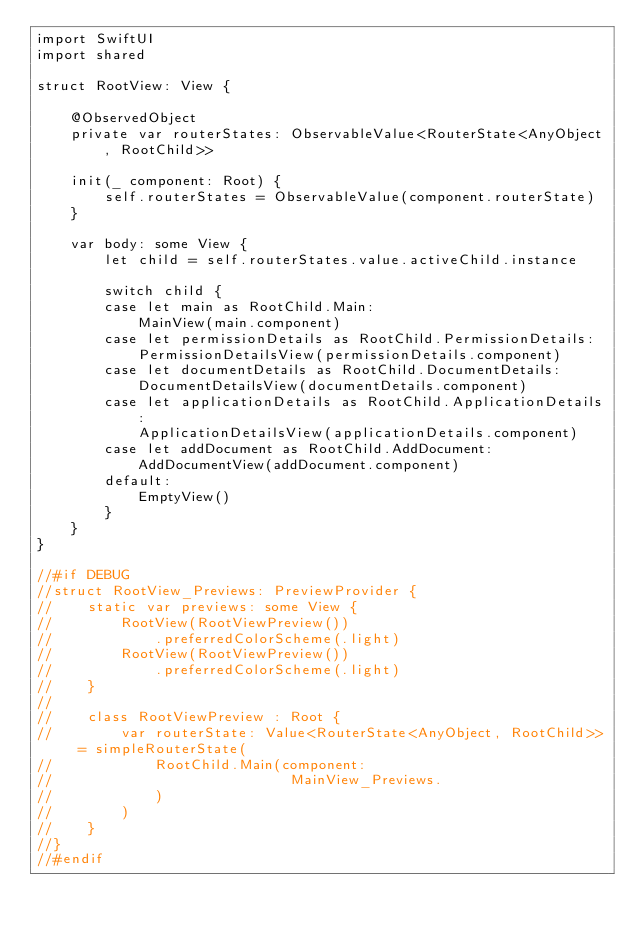Convert code to text. <code><loc_0><loc_0><loc_500><loc_500><_Swift_>import SwiftUI
import shared

struct RootView: View {
    
    @ObservedObject
    private var routerStates: ObservableValue<RouterState<AnyObject, RootChild>>
    
    init(_ component: Root) {
        self.routerStates = ObservableValue(component.routerState)
    }
    
    var body: some View {
        let child = self.routerStates.value.activeChild.instance
        
        switch child {
        case let main as RootChild.Main:
            MainView(main.component)
        case let permissionDetails as RootChild.PermissionDetails:
            PermissionDetailsView(permissionDetails.component)
        case let documentDetails as RootChild.DocumentDetails:
            DocumentDetailsView(documentDetails.component)
        case let applicationDetails as RootChild.ApplicationDetails:
            ApplicationDetailsView(applicationDetails.component)
        case let addDocument as RootChild.AddDocument:
            AddDocumentView(addDocument.component)
        default:
            EmptyView()
        }
    }
}

//#if DEBUG
//struct RootView_Previews: PreviewProvider {
//    static var previews: some View {
//        RootView(RootViewPreview())
//            .preferredColorScheme(.light)
//        RootView(RootViewPreview())
//            .preferredColorScheme(.light)
//    }
//    
//    class RootViewPreview : Root {
//        var routerState: Value<RouterState<AnyObject, RootChild>> = simpleRouterState(
//            RootChild.Main(component:
//                            MainView_Previews.
//            )
//        )
//    }
//}
//#endif
</code> 